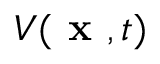<formula> <loc_0><loc_0><loc_500><loc_500>V ( x , t )</formula> 